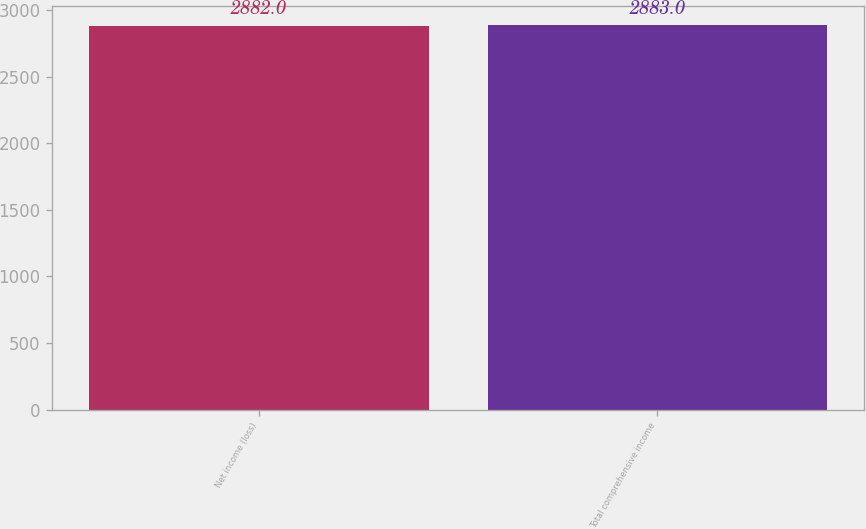Convert chart to OTSL. <chart><loc_0><loc_0><loc_500><loc_500><bar_chart><fcel>Net income (loss)<fcel>Total comprehensive income<nl><fcel>2882<fcel>2883<nl></chart> 